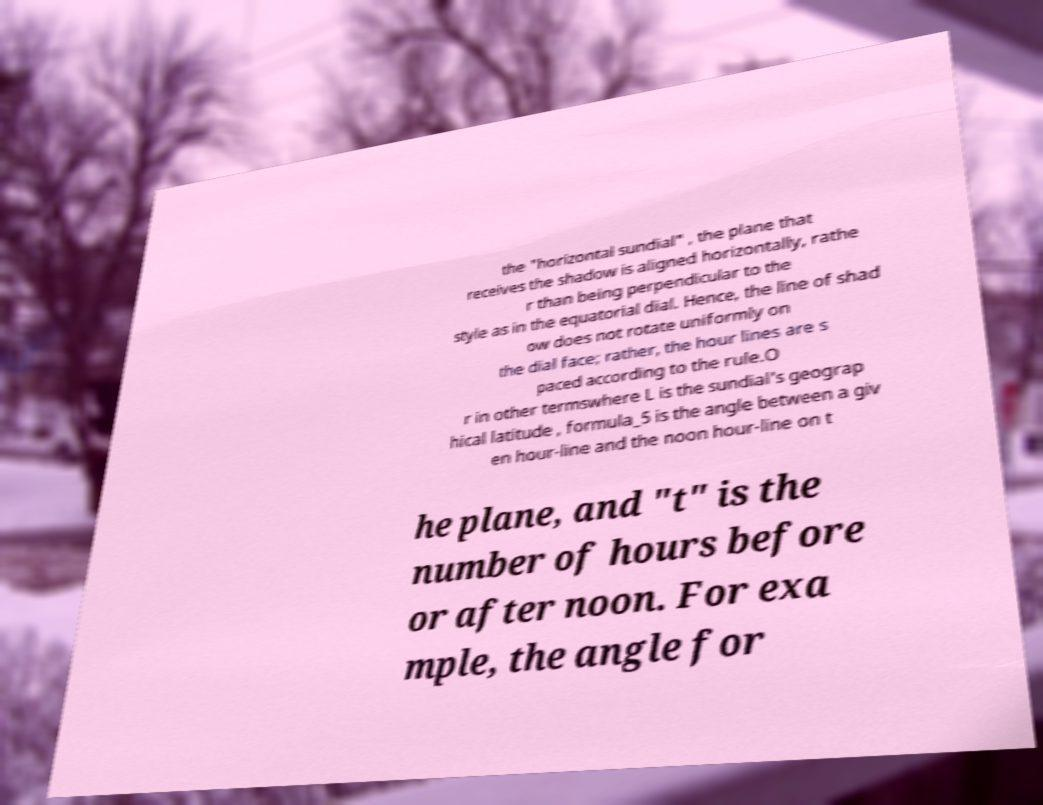Please read and relay the text visible in this image. What does it say? the "horizontal sundial" , the plane that receives the shadow is aligned horizontally, rathe r than being perpendicular to the style as in the equatorial dial. Hence, the line of shad ow does not rotate uniformly on the dial face; rather, the hour lines are s paced according to the rule.O r in other termswhere L is the sundial's geograp hical latitude , formula_5 is the angle between a giv en hour-line and the noon hour-line on t he plane, and "t" is the number of hours before or after noon. For exa mple, the angle for 